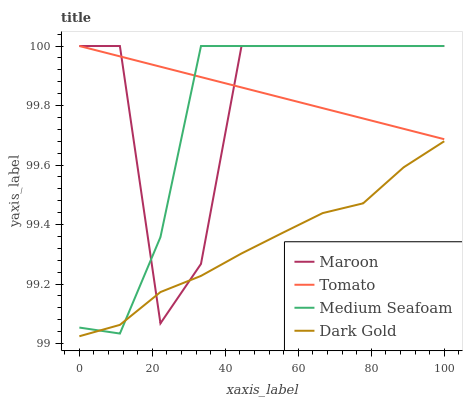Does Dark Gold have the minimum area under the curve?
Answer yes or no. Yes. Does Tomato have the maximum area under the curve?
Answer yes or no. Yes. Does Medium Seafoam have the minimum area under the curve?
Answer yes or no. No. Does Medium Seafoam have the maximum area under the curve?
Answer yes or no. No. Is Tomato the smoothest?
Answer yes or no. Yes. Is Maroon the roughest?
Answer yes or no. Yes. Is Medium Seafoam the smoothest?
Answer yes or no. No. Is Medium Seafoam the roughest?
Answer yes or no. No. Does Dark Gold have the lowest value?
Answer yes or no. Yes. Does Medium Seafoam have the lowest value?
Answer yes or no. No. Does Maroon have the highest value?
Answer yes or no. Yes. Does Dark Gold have the highest value?
Answer yes or no. No. Is Dark Gold less than Tomato?
Answer yes or no. Yes. Is Tomato greater than Dark Gold?
Answer yes or no. Yes. Does Tomato intersect Medium Seafoam?
Answer yes or no. Yes. Is Tomato less than Medium Seafoam?
Answer yes or no. No. Is Tomato greater than Medium Seafoam?
Answer yes or no. No. Does Dark Gold intersect Tomato?
Answer yes or no. No. 